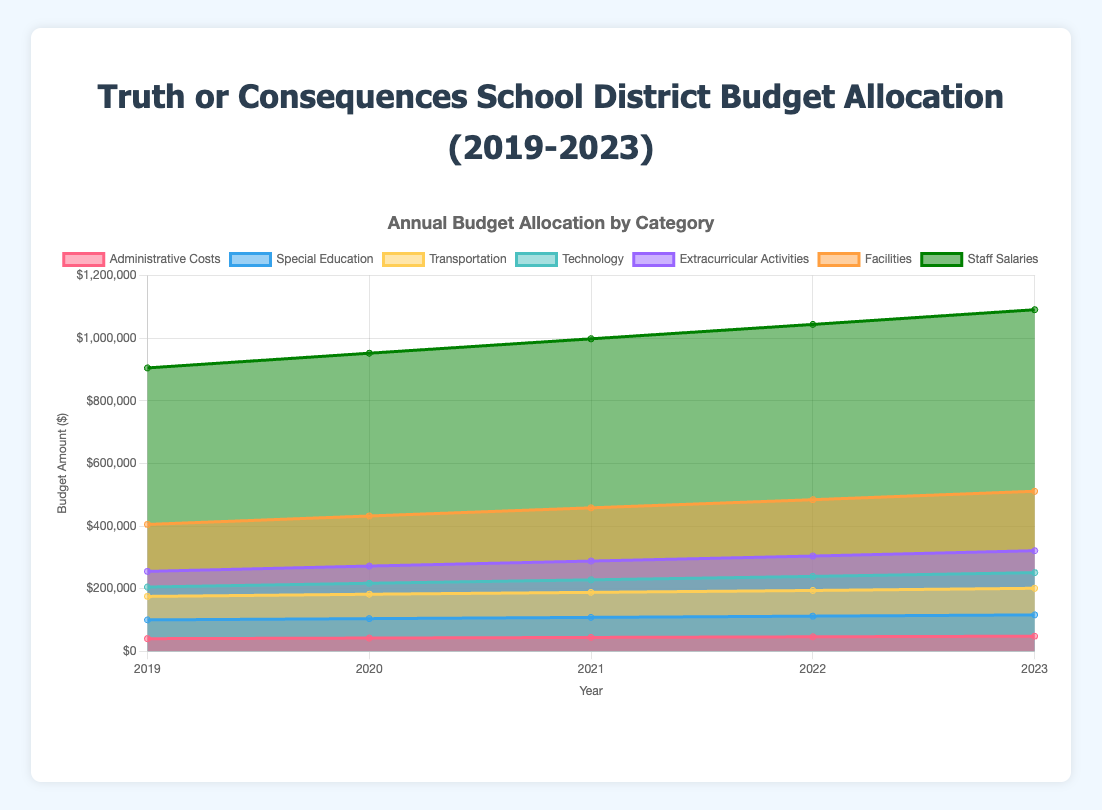What is the title of the chart? The title of the chart is displayed at the top and reads "Truth or Consequences School District Budget Allocation (2019-2023)".
Answer: Truth or Consequences School District Budget Allocation (2019-2023) Which category has the highest budget allocation in 2022? The category with the highest budget allocation can be identified by looking at the topmost areas at the 2022 marker. The "Staff Salaries" category extends the highest.
Answer: Staff Salaries How much was allocated to Technology in 2020? Find the segment labeled "Technology" for the year 2020. The value is 35,000.
Answer: $35,000 Did the budget allocation for Facilities increase or decrease every year from 2019 to 2023? Check the Facilities budget column from 2019 to 2023: 150,000 (2019), 160,000 (2020), 170,000 (2021), 180,000 (2022), 190,000 (2023). The values consistently increase each year.
Answer: Increase By how much did the budget for Extracurricular Activities change from 2019 to 2023? Subtract the budget for Extracurricular Activities in 2019 from the budget in 2023: 70,000 (2023) - 50,000 (2019) = 20,000
Answer: $20,000 